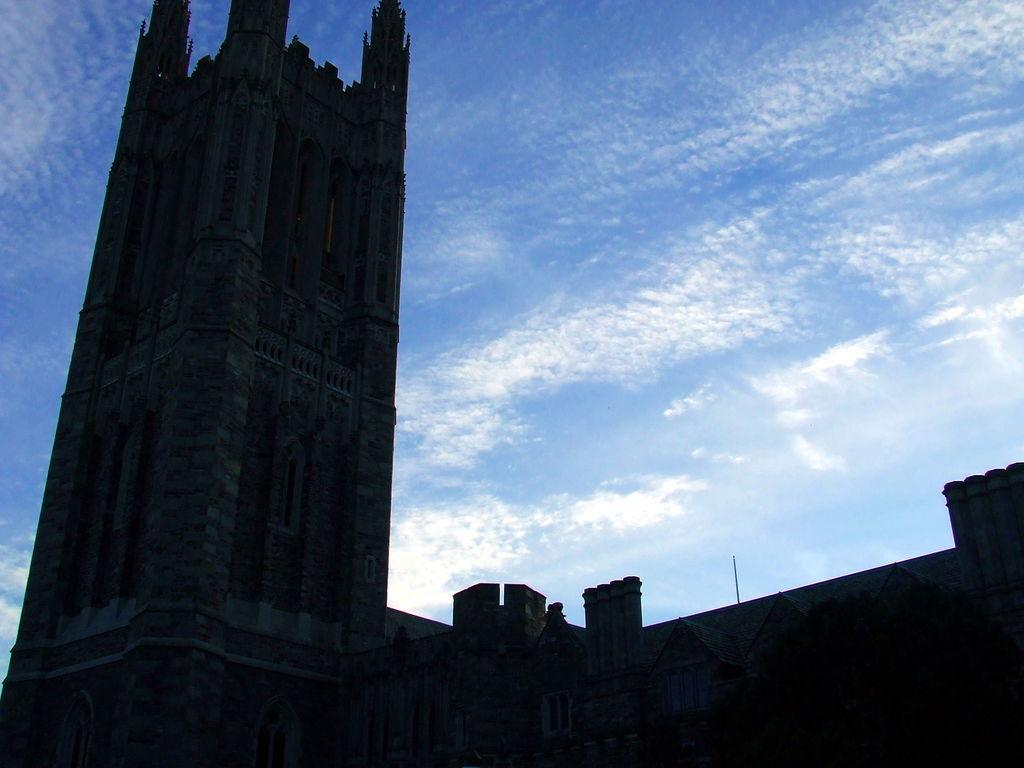How would you summarize this image in a sentence or two? In this image we can see buildings and sky with clouds in the background. 